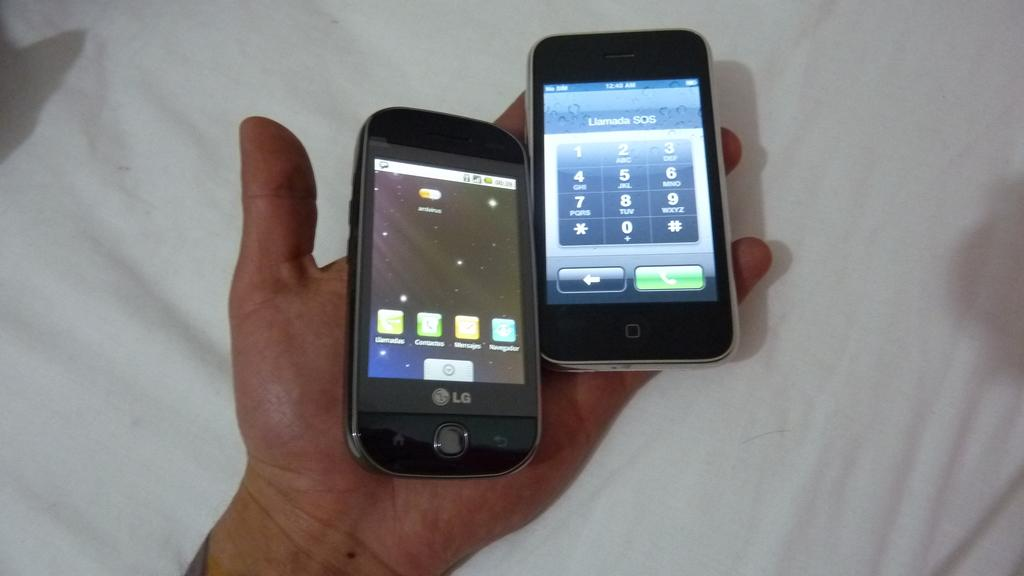<image>
Give a short and clear explanation of the subsequent image. An LG phone is being held in a hand next to another phone. 